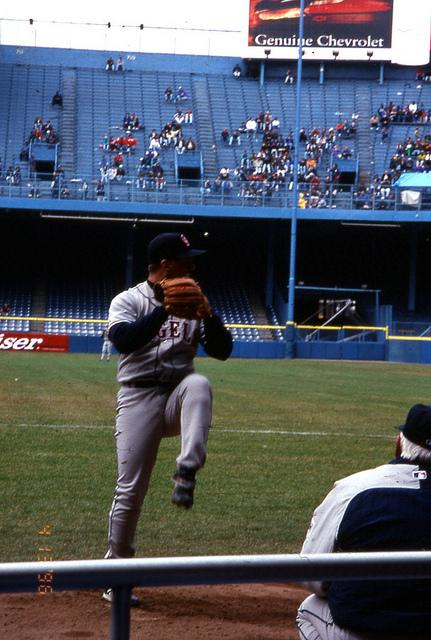What is the nickname of the motor vehicle company advertised? chevy 